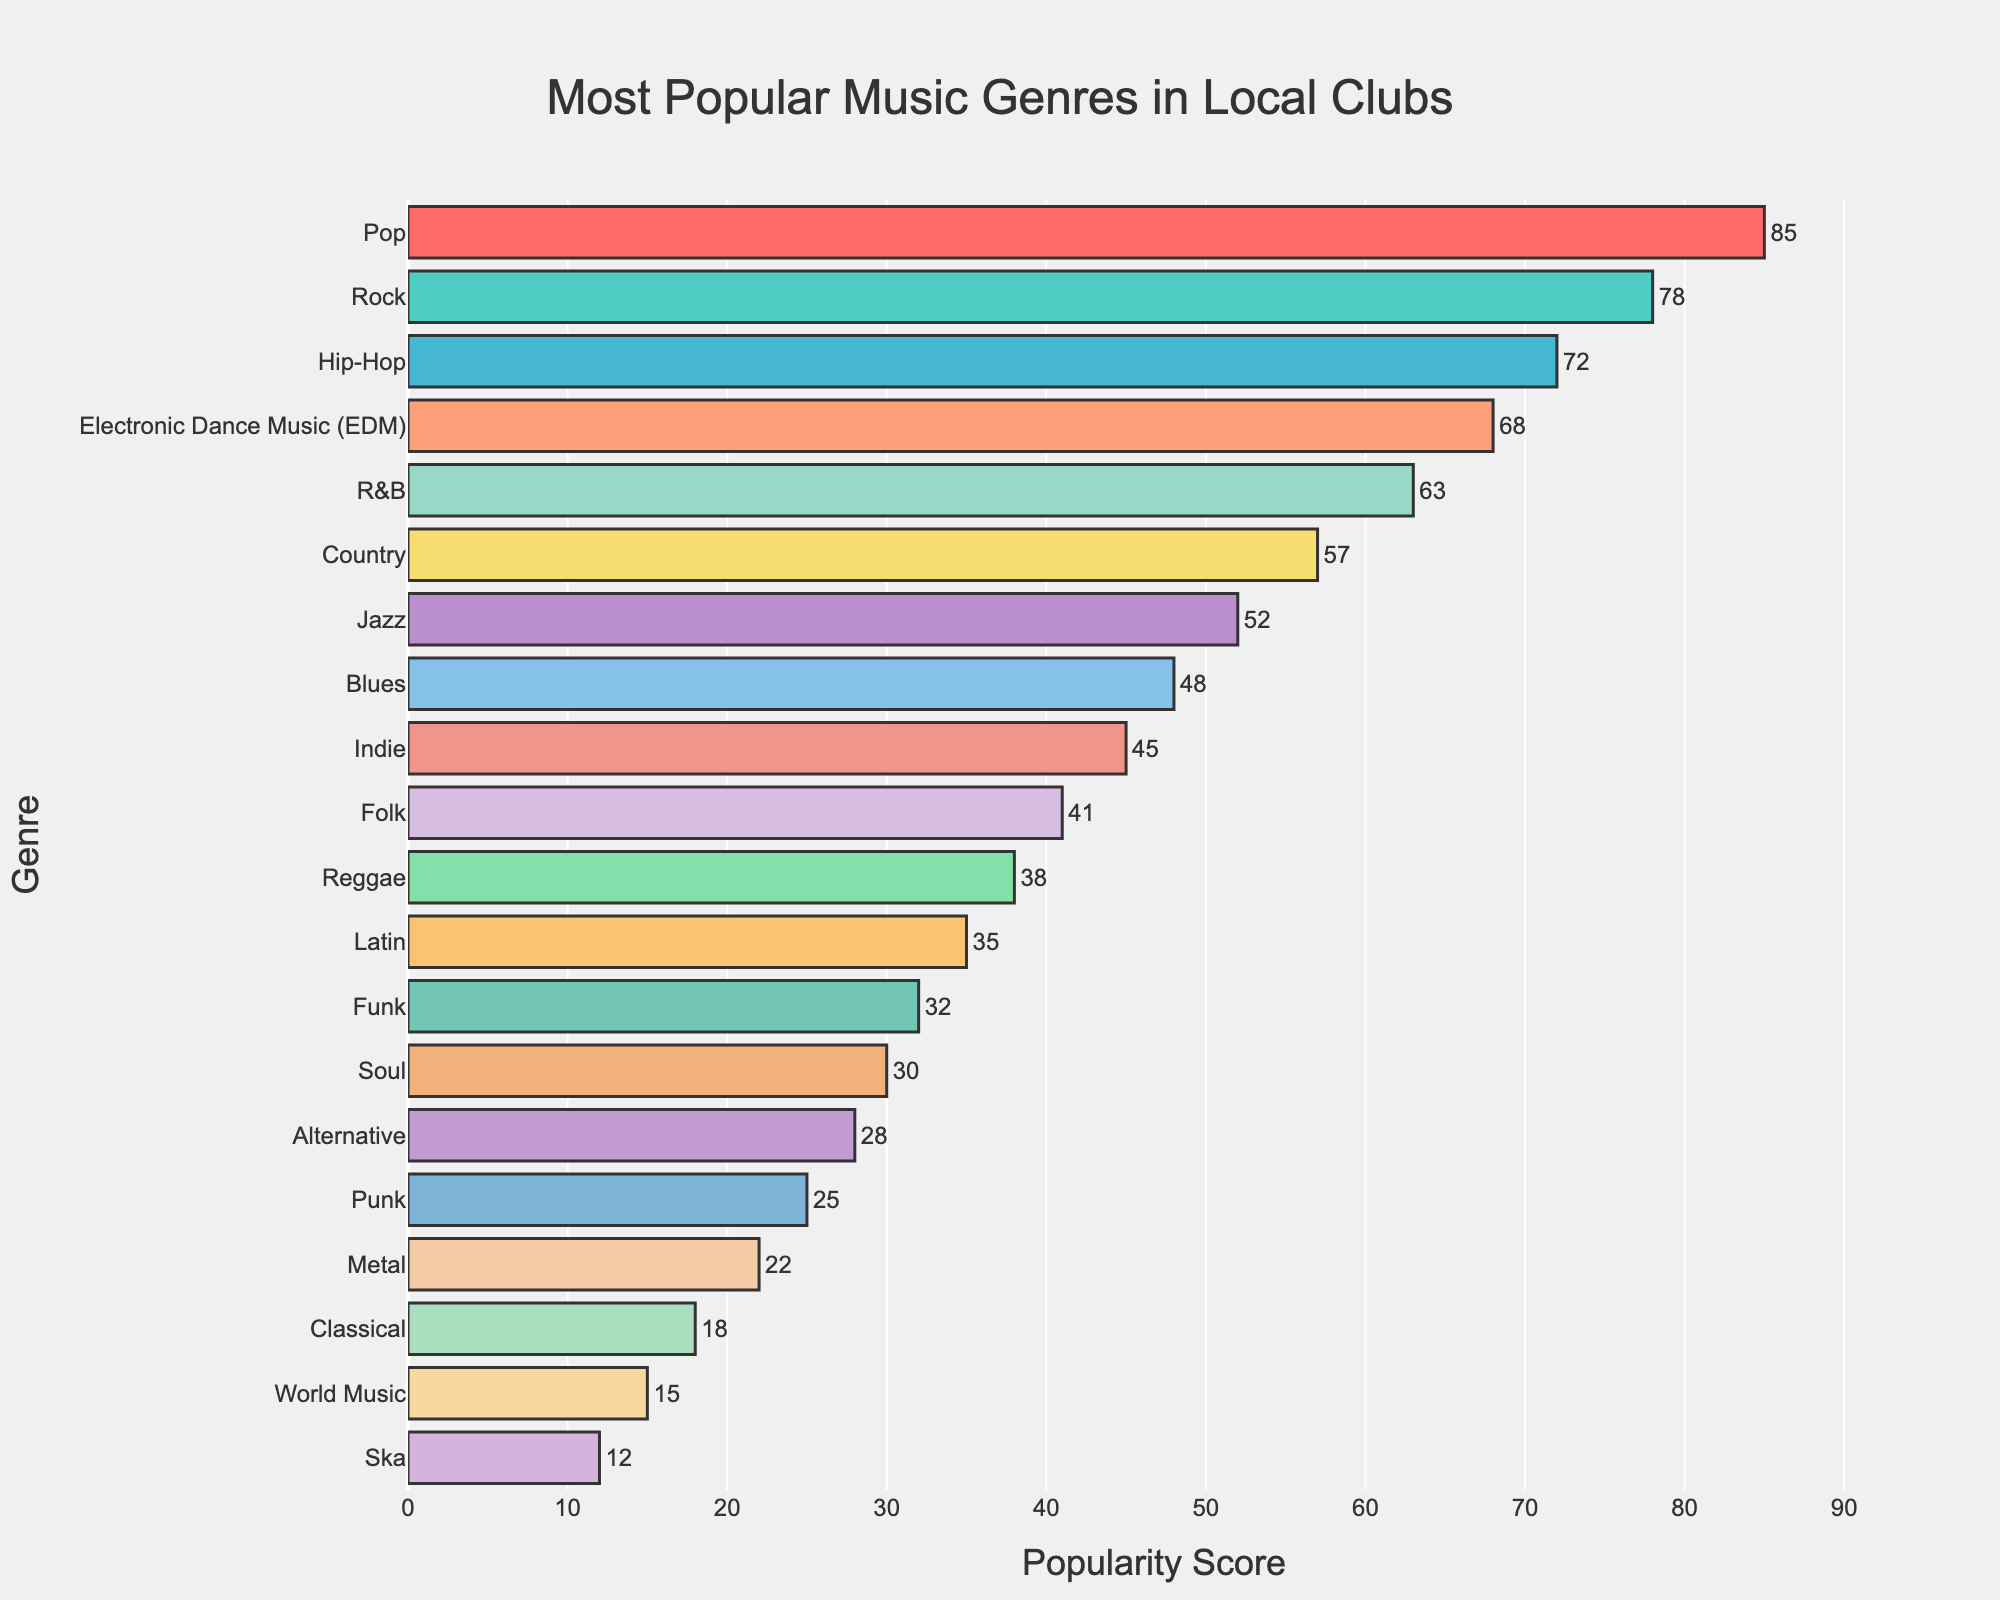Which genre is most popular in the local clubs? Look for the bar with the highest value. The longest bar represents the most popular genre. The 'Pop' genre has the highest popularity score of 85.
Answer: Pop Which genre has the least popularity in the local clubs? Find the shortest bar in the chart, which represents the least popular genre. The 'Ska' genre has the lowest popularity score of 12.
Answer: Ska What is the combined popularity score of Rock and Hip-Hop? Identify the popularity scores for Rock and Hip-Hop and sum them up. Rock has a score of 78 and Hip-Hop has a score of 72. The combined score is 78 + 72 = 150.
Answer: 150 How much more popular is EDM than Latin? Subtract the popularity score of Latin from EDM to find the difference. EDM has a score of 68, and Latin has a score of 35. The difference is 68 - 35 = 33.
Answer: 33 Which genre is more popular, Country or Jazz, and by how much? Compare the popularity scores of Country and Jazz. Country has a score of 57, and Jazz has a score of 52. Country is more popular by 57 - 52 = 5 points.
Answer: Country by 5 points List the genres that have a popularity score greater than 60. Identify all bars with values above 60. The genres with scores above 60 are Pop (85), Rock (78), Hip-Hop (72), EDM (68), and R&B (63).
Answer: Pop, Rock, Hip-Hop, EDM, R&B Calculate the average popularity score of the genres Pop, Rock, and EDM. Add the popularity scores of Pop, Rock, and EDM, then divide by the number of genres. Pop has 85, Rock has 78, and EDM has 68. The sum is 85 + 78 + 68 = 231. The average is 231 / 3 = 77.
Answer: 77 What color represents the genre 'Soul' in the bar chart? Identify the bar corresponding to 'Soul' to determine its color. The bar for 'Soul' is in purple.
Answer: Purple Which is the only genre with a popularity score between 30 and 35? Look for the bar whose score falls within the specified range. Latin has a score of 35, which fits the criteria.
Answer: Latin How many genres have a popularity score below 50? Count the number of bars representing genres with scores less than 50. The genres are Blues (48), Indie (45), Folk (41), Reggae (38), Latin (35), Funk (32), Soul (30), Alternative (28), Punk (25), Metal (22), Classical (18), and Ska (12), making a total of 12 genres.
Answer: 12 